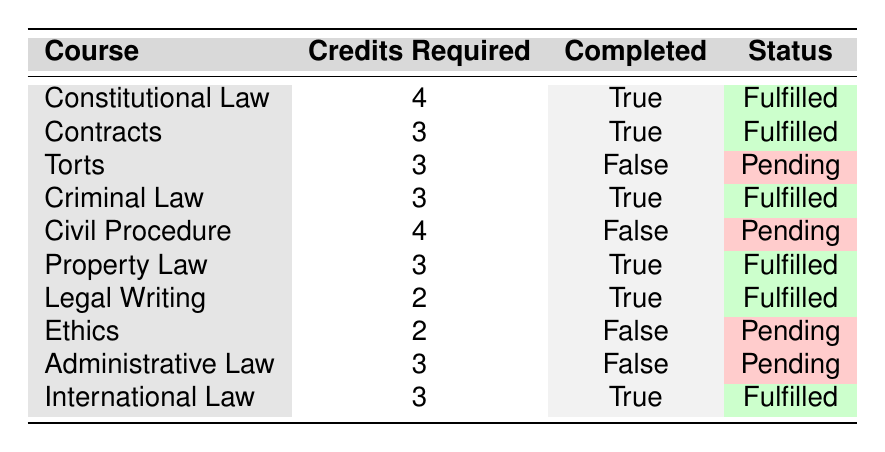What is the total number of credits required for the completed courses? To find this, we need to look at the courses marked as "Completed" and sum their "Credits Required". The completed courses are: Constitutional Law (4), Contracts (3), Criminal Law (3), Property Law (3), Legal Writing (2), and International Law (3). Adding these gives 4 + 3 + 3 + 3 + 2 + 3 = 18.
Answer: 18 Which course has the highest credit requirement and what is its status? By examining the "Credits Required" column, the course with the highest requirement is Constitutional Law, which requires 4 credits. Since it is marked as "Completed", its status is Fulfilled.
Answer: Constitutional Law, Fulfilled Are there any courses with a "Pending" status that require 3 or more credits? Looking at the courses marked as "Pending", we have Torts (3), Civil Procedure (4), Ethics (2), and Administrative Law (3). Among these, Torts (3), Civil Procedure (4), and Administrative Law (3) all meet the criteria of requiring 3 or more credits.
Answer: Yes What is the total number of courses required for the law degree? We simply count all the courses listed in the table. There are 10 courses in total.
Answer: 10 How many courses have been completed with fewer than 3 credits? We check the completed courses first: The only completed course with fewer than 3 credits is Legal Writing, which has 2 credits. Therefore, there is 1 such course.
Answer: 1 Which course is the only one with a status of "Pending" and requires 2 credits? Referring to the "Pending" status courses, the only course that requires 2 credits is Ethics.
Answer: Ethics How many total credits are required for the courses that are marked as "Pending"? The "Pending" courses are Torts (3), Civil Procedure (4), Ethics (2), and Administrative Law (3). Therefore, the total required credits are 3 + 4 + 2 + 3 = 12.
Answer: 12 Which courses have been completed in the same category of law? The completed courses in similar categories include: Constitutional Law, Criminal Law, and International Law (all are part of core legal studies) along with Property Law (real property). Thus, there is a total of 4 completed courses in similar areas.
Answer: 4 